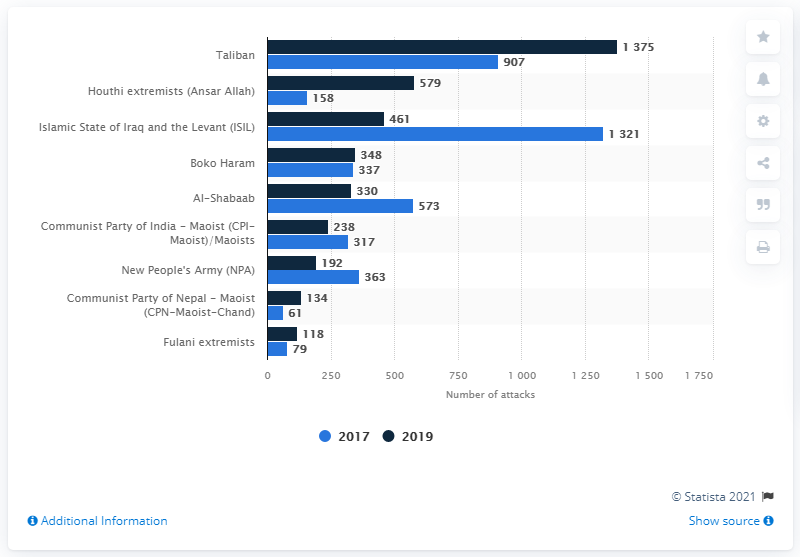Draw attention to some important aspects in this diagram. Please provide the difference between the two longest bars, one being light blue and the other being dark blue, stated as 54.. According to data from 2019, the Taliban was the most active perpetrator group worldwide in terms of the number of attacks. 